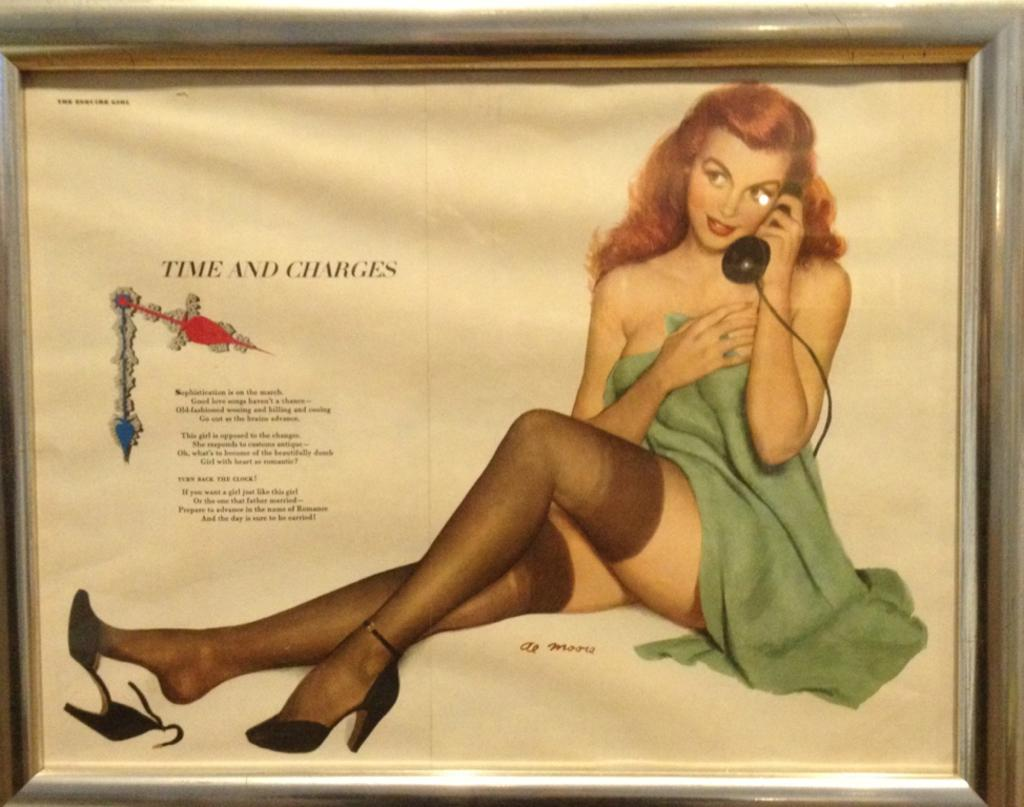What object can be seen in the image that people write or draw on? There is a board in the image that people can write or draw on. What is the lady in the image doing? The lady in the image is holding a telephone and sitting. Can you describe what is written or displayed on the board? There is text visible on the board. What type of sock is the lady wearing in the image? There is no information about the lady's socks in the image, so we cannot determine what type of sock she is wearing. 